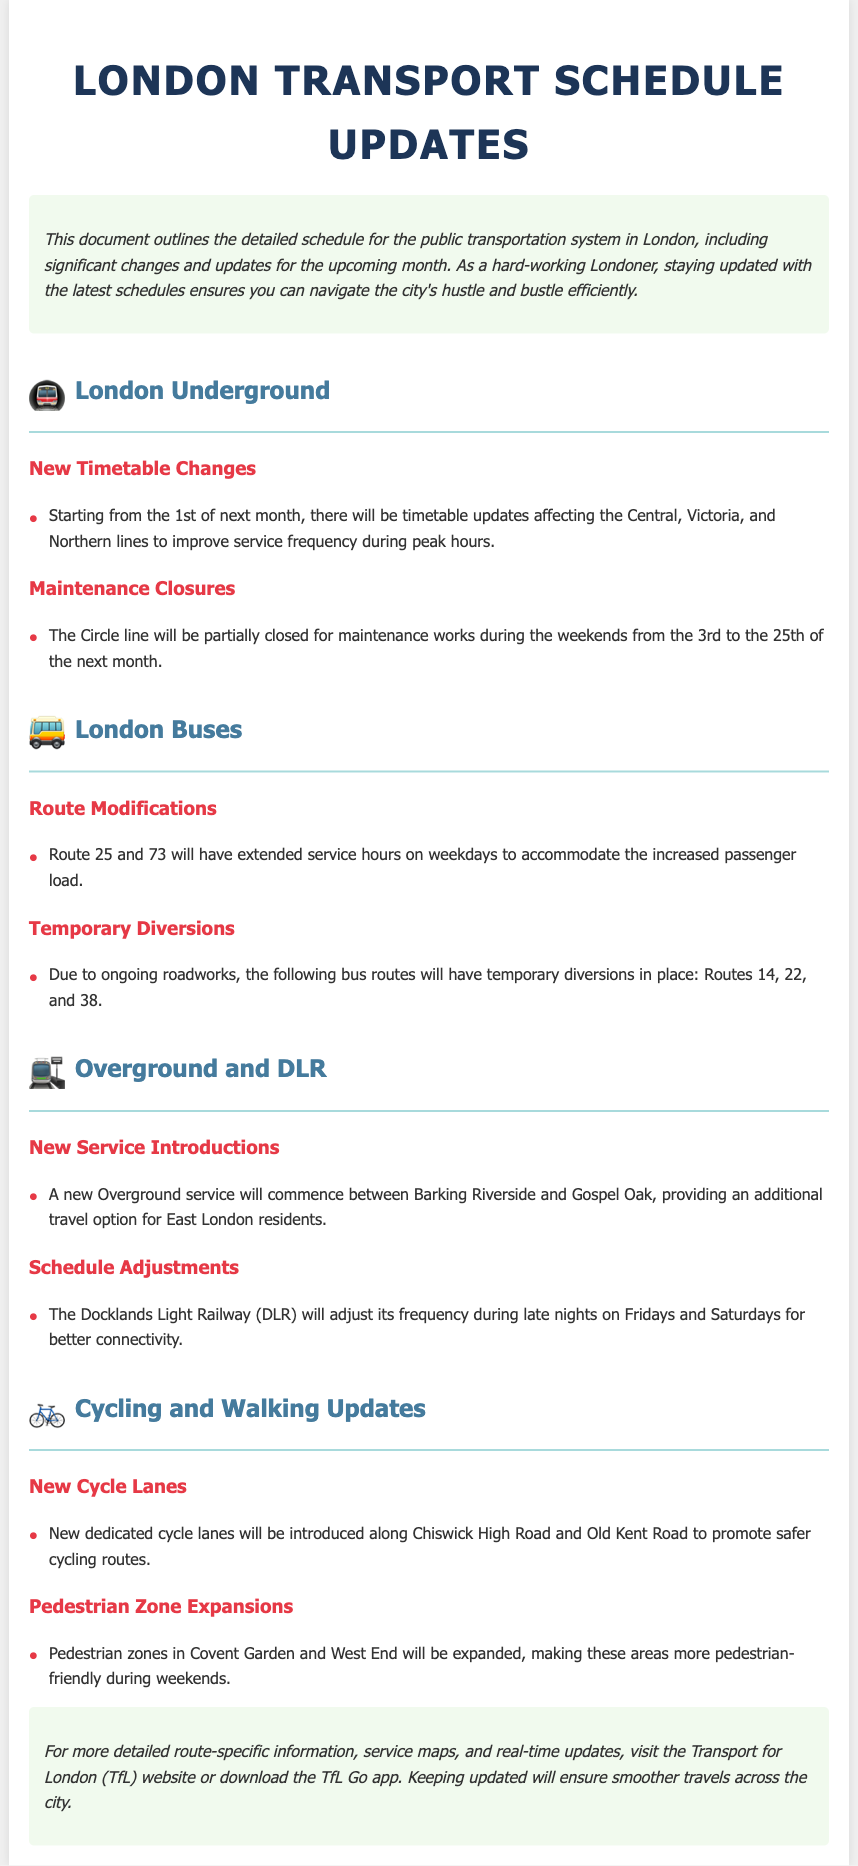What changes are happening to the Central line? The document states there will be timetable updates affecting the Central line starting from the 1st of next month.
Answer: timetable updates What is the duration of the Circle line maintenance closure? The Circle line will be partially closed for maintenance works during the weekends from the 3rd to the 25th of the next month.
Answer: 3rd to 25th Which bus routes are undergoing temporary diversions? The document lists Routes 14, 22, and 38 as having temporary diversions due to ongoing roadworks.
Answer: 14, 22, 38 What new service is being introduced in East London? A new Overground service will commence between Barking Riverside and Gospel Oak.
Answer: Barking Riverside and Gospel Oak How will the DLR's frequency change on weekends? The document indicates that the Docklands Light Railway (DLR) will adjust its frequency during late nights on Fridays and Saturdays.
Answer: late nights What road is mentioned for the new dedicated cycle lanes? The document mentions new dedicated cycle lanes being introduced along Chiswick High Road.
Answer: Chiswick High Road What zones are being expanded in the upcoming changes? The pedestrian zones in Covent Garden and West End will be expanded as stated in the document.
Answer: Covent Garden and West End What resource can be used for real-time updates? The document recommends visiting the Transport for London (TfL) website or downloading the TfL Go app for real-time updates.
Answer: TfL website or TfL Go app 